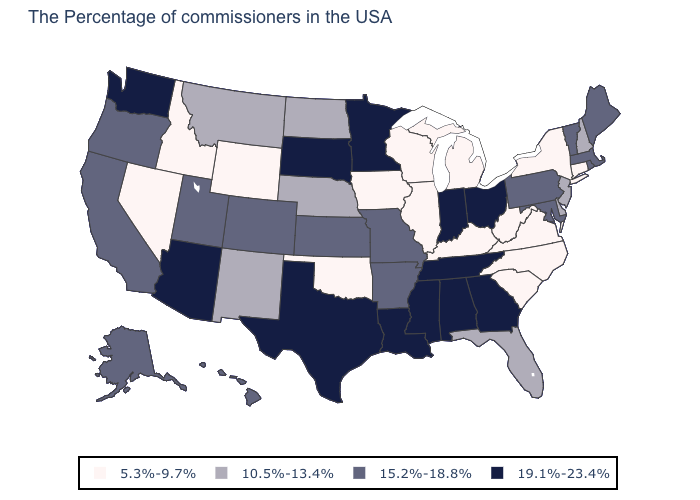Does the map have missing data?
Write a very short answer. No. Name the states that have a value in the range 10.5%-13.4%?
Quick response, please. New Hampshire, New Jersey, Delaware, Florida, Nebraska, North Dakota, New Mexico, Montana. How many symbols are there in the legend?
Write a very short answer. 4. What is the value of Pennsylvania?
Be succinct. 15.2%-18.8%. What is the highest value in states that border Washington?
Write a very short answer. 15.2%-18.8%. What is the value of Nevada?
Quick response, please. 5.3%-9.7%. Name the states that have a value in the range 5.3%-9.7%?
Short answer required. Connecticut, New York, Virginia, North Carolina, South Carolina, West Virginia, Michigan, Kentucky, Wisconsin, Illinois, Iowa, Oklahoma, Wyoming, Idaho, Nevada. What is the value of Alaska?
Answer briefly. 15.2%-18.8%. Among the states that border North Dakota , does Montana have the highest value?
Answer briefly. No. What is the highest value in the MidWest ?
Answer briefly. 19.1%-23.4%. Which states hav the highest value in the West?
Write a very short answer. Arizona, Washington. What is the value of New Jersey?
Concise answer only. 10.5%-13.4%. Name the states that have a value in the range 10.5%-13.4%?
Short answer required. New Hampshire, New Jersey, Delaware, Florida, Nebraska, North Dakota, New Mexico, Montana. Name the states that have a value in the range 15.2%-18.8%?
Give a very brief answer. Maine, Massachusetts, Rhode Island, Vermont, Maryland, Pennsylvania, Missouri, Arkansas, Kansas, Colorado, Utah, California, Oregon, Alaska, Hawaii. What is the value of New Mexico?
Quick response, please. 10.5%-13.4%. 